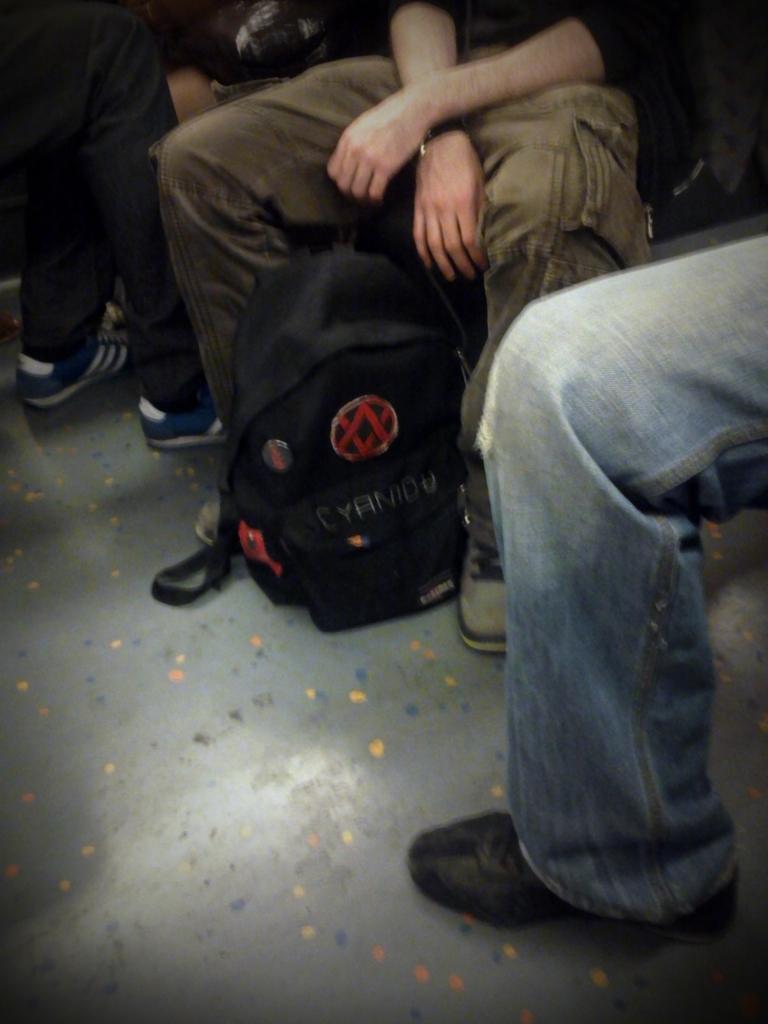Describe this image in one or two sentences. In this picture we can see two people sitting and a person is standing on the floor. We can see a bag on the floor. 